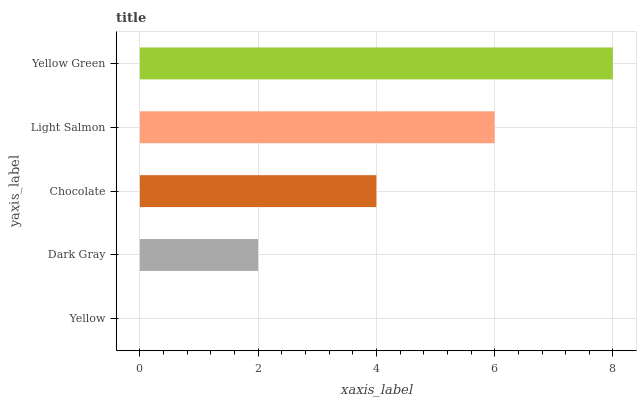Is Yellow the minimum?
Answer yes or no. Yes. Is Yellow Green the maximum?
Answer yes or no. Yes. Is Dark Gray the minimum?
Answer yes or no. No. Is Dark Gray the maximum?
Answer yes or no. No. Is Dark Gray greater than Yellow?
Answer yes or no. Yes. Is Yellow less than Dark Gray?
Answer yes or no. Yes. Is Yellow greater than Dark Gray?
Answer yes or no. No. Is Dark Gray less than Yellow?
Answer yes or no. No. Is Chocolate the high median?
Answer yes or no. Yes. Is Chocolate the low median?
Answer yes or no. Yes. Is Yellow the high median?
Answer yes or no. No. Is Yellow Green the low median?
Answer yes or no. No. 